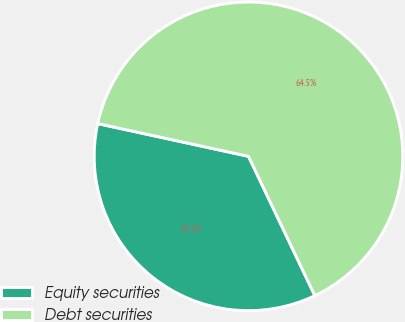Convert chart to OTSL. <chart><loc_0><loc_0><loc_500><loc_500><pie_chart><fcel>Equity securities<fcel>Debt securities<nl><fcel>35.48%<fcel>64.52%<nl></chart> 